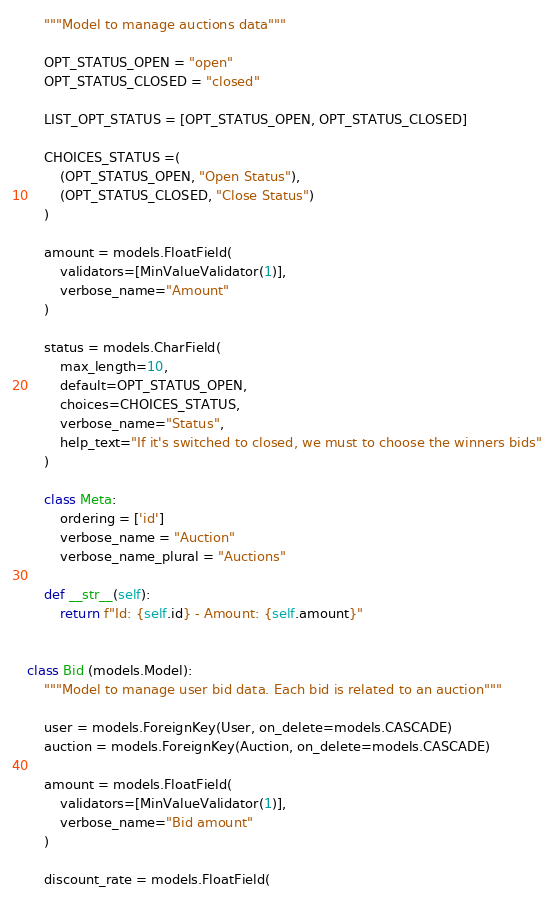Convert code to text. <code><loc_0><loc_0><loc_500><loc_500><_Python_>    """Model to manage auctions data"""

    OPT_STATUS_OPEN = "open"
    OPT_STATUS_CLOSED = "closed"

    LIST_OPT_STATUS = [OPT_STATUS_OPEN, OPT_STATUS_CLOSED]

    CHOICES_STATUS =(
        (OPT_STATUS_OPEN, "Open Status"),
        (OPT_STATUS_CLOSED, "Close Status")
    )

    amount = models.FloatField(
        validators=[MinValueValidator(1)],
        verbose_name="Amount"
    )

    status = models.CharField(
        max_length=10,
        default=OPT_STATUS_OPEN,
        choices=CHOICES_STATUS,
        verbose_name="Status",
        help_text="If it's switched to closed, we must to choose the winners bids"
    )

    class Meta:
        ordering = ['id']
        verbose_name = "Auction"
        verbose_name_plural = "Auctions"

    def __str__(self):
        return f"Id: {self.id} - Amount: {self.amount}"


class Bid (models.Model):
    """Model to manage user bid data. Each bid is related to an auction"""

    user = models.ForeignKey(User, on_delete=models.CASCADE)
    auction = models.ForeignKey(Auction, on_delete=models.CASCADE)

    amount = models.FloatField(
        validators=[MinValueValidator(1)],
        verbose_name="Bid amount"
    )

    discount_rate = models.FloatField(</code> 